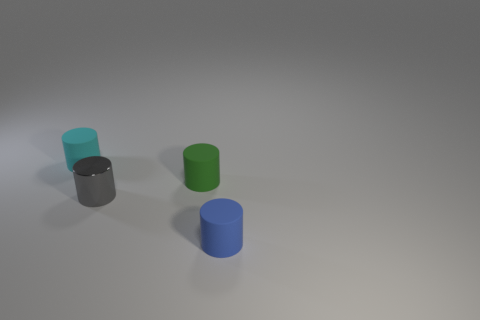Add 1 cyan matte cylinders. How many objects exist? 5 Subtract all small rubber cylinders. How many cylinders are left? 1 Subtract all blue cylinders. How many cylinders are left? 3 Subtract 0 green blocks. How many objects are left? 4 Subtract all brown cylinders. Subtract all brown cubes. How many cylinders are left? 4 Subtract all tiny cyan rubber cylinders. Subtract all metallic objects. How many objects are left? 2 Add 2 green matte things. How many green matte things are left? 3 Add 2 tiny gray things. How many tiny gray things exist? 3 